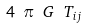<formula> <loc_0><loc_0><loc_500><loc_500>4 \ \pi \ G \ T _ { i j }</formula> 